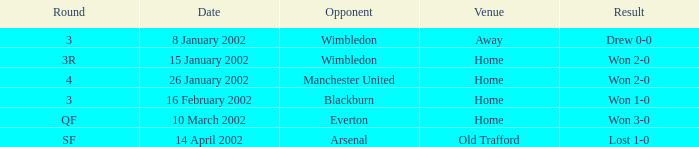What is the Date with an Opponent with wimbledon, and a Result of drew 0-0? 8 January 2002. 